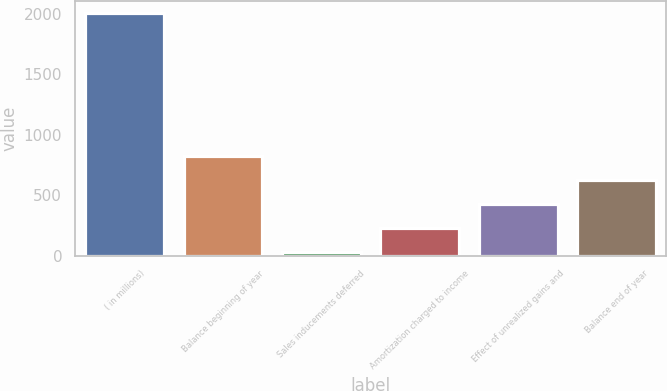Convert chart. <chart><loc_0><loc_0><loc_500><loc_500><bar_chart><fcel>( in millions)<fcel>Balance beginning of year<fcel>Sales inducements deferred<fcel>Amortization charged to income<fcel>Effect of unrealized gains and<fcel>Balance end of year<nl><fcel>2009<fcel>820.4<fcel>28<fcel>226.1<fcel>424.2<fcel>622.3<nl></chart> 